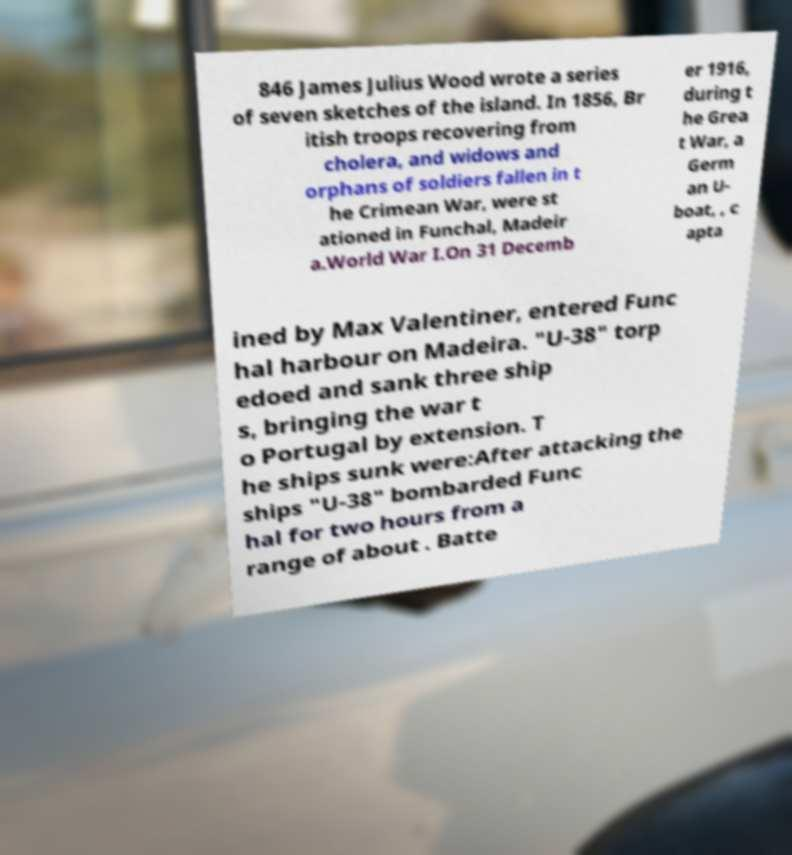For documentation purposes, I need the text within this image transcribed. Could you provide that? 846 James Julius Wood wrote a series of seven sketches of the island. In 1856, Br itish troops recovering from cholera, and widows and orphans of soldiers fallen in t he Crimean War, were st ationed in Funchal, Madeir a.World War I.On 31 Decemb er 1916, during t he Grea t War, a Germ an U- boat, , c apta ined by Max Valentiner, entered Func hal harbour on Madeira. "U-38" torp edoed and sank three ship s, bringing the war t o Portugal by extension. T he ships sunk were:After attacking the ships "U-38" bombarded Func hal for two hours from a range of about . Batte 